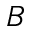Convert formula to latex. <formula><loc_0><loc_0><loc_500><loc_500>B</formula> 